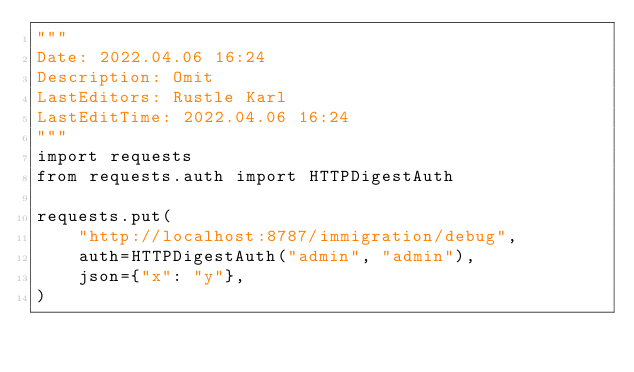Convert code to text. <code><loc_0><loc_0><loc_500><loc_500><_Python_>"""
Date: 2022.04.06 16:24
Description: Omit
LastEditors: Rustle Karl
LastEditTime: 2022.04.06 16:24
"""
import requests
from requests.auth import HTTPDigestAuth

requests.put(
    "http://localhost:8787/immigration/debug",
    auth=HTTPDigestAuth("admin", "admin"),
    json={"x": "y"},
)
</code> 